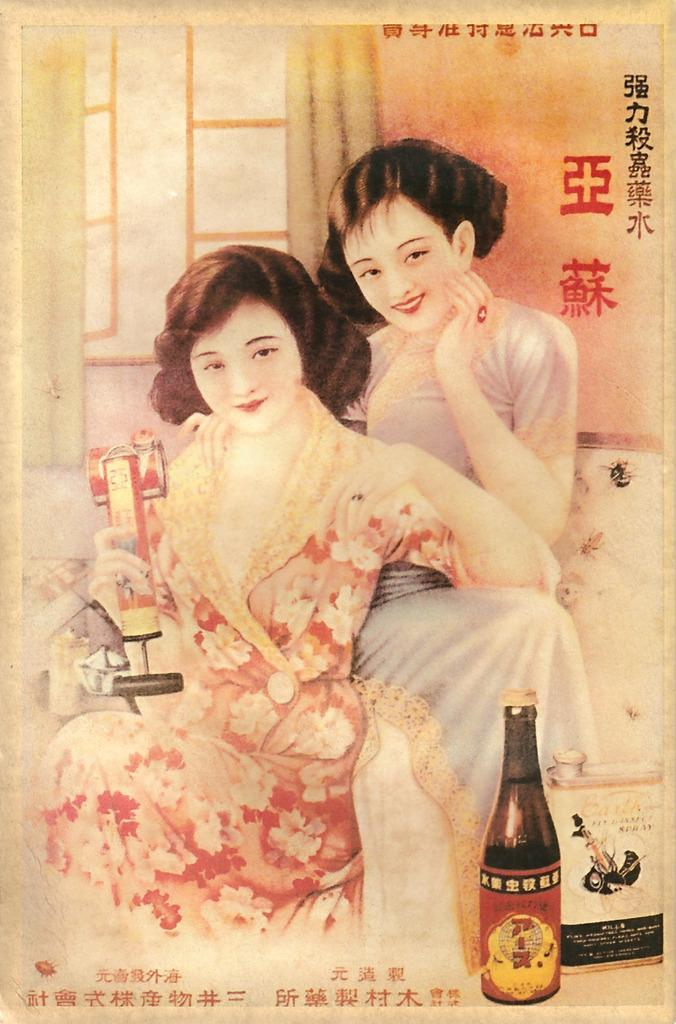How many people are present in the image? There are two women in the image. What is one of the women doing in the image? One of the women is holding an object. Can you describe any other objects in the image? There is a bottle in the image. What can be seen in the background of the image? There is a window and a curtain associated with the window in the background of the image. What type of breakfast is being prepared on the marble countertop in the image? There is no mention of a marble countertop or breakfast in the image; it only features two women, one holding an object, a bottle, and a window with a curtain. 